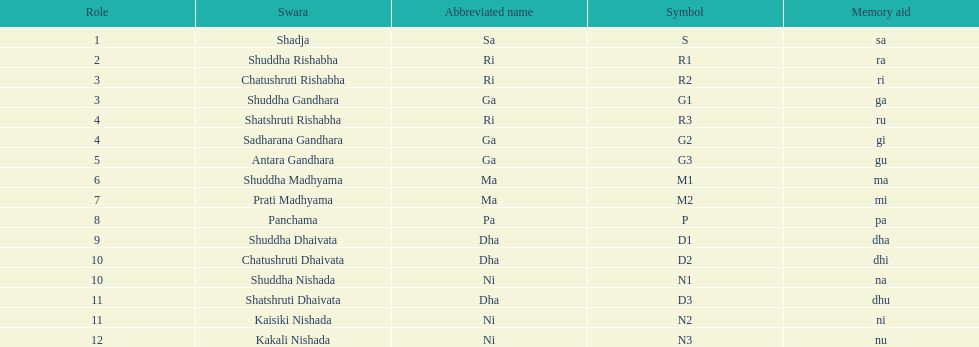Which swara is situated in the first position by name? Shadja. 